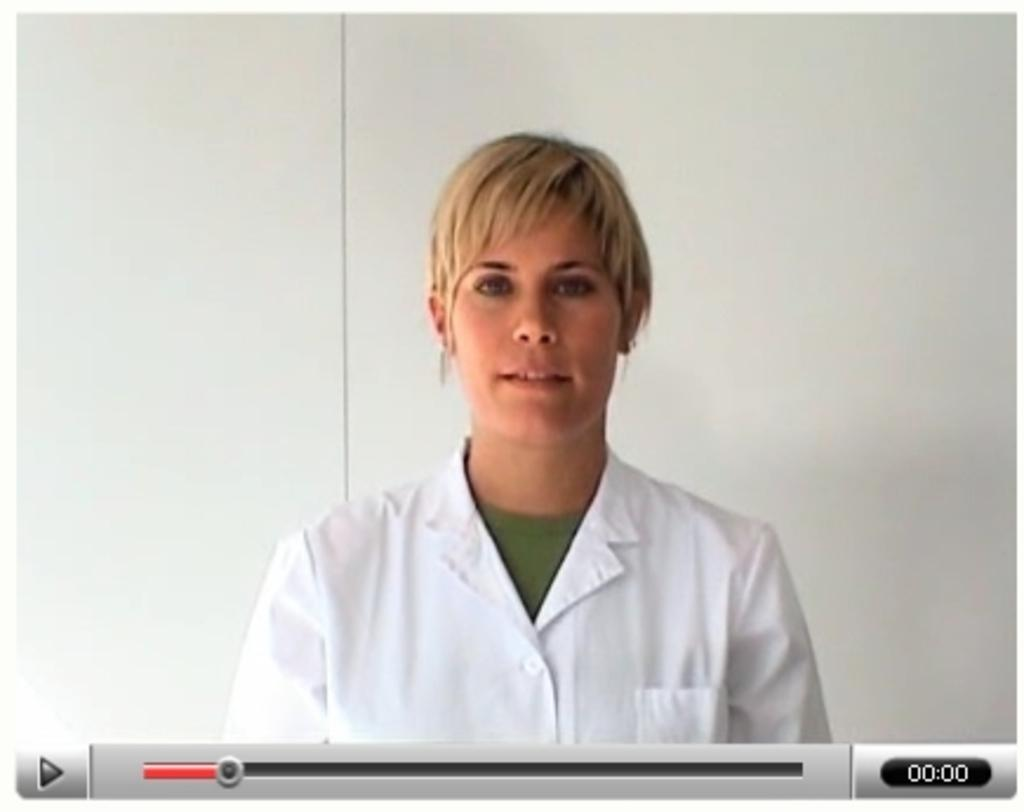Who is present in the image? There is a woman in the image. What is the woman wearing? The woman is wearing a white apron. What can be seen in the background of the image? There is a wall in the background of the image. What scientific theory is the woman discussing in the image? There is no indication in the image that the woman is discussing any scientific theory. 